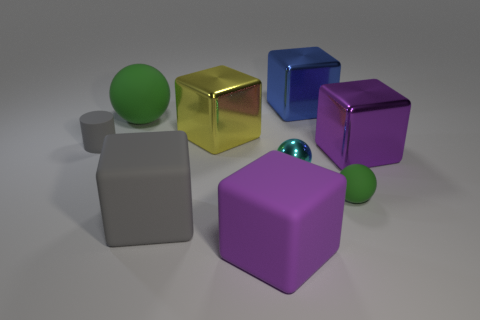What shape is the large matte object that is the same color as the small matte cylinder?
Make the answer very short. Cube. There is a large purple cube behind the purple block that is to the left of the small rubber ball; how many large purple blocks are in front of it?
Provide a short and direct response. 1. How many purple things are right of the large purple rubber block and in front of the small cyan shiny thing?
Offer a very short reply. 0. Is there anything else of the same color as the tiny matte sphere?
Make the answer very short. Yes. How many shiny objects are small green balls or tiny purple cylinders?
Provide a short and direct response. 0. What material is the small ball left of the tiny green matte object that is to the left of the big metallic block that is right of the blue metallic cube?
Your answer should be compact. Metal. There is a small object that is to the left of the large matte object to the right of the large gray rubber block; what is it made of?
Offer a very short reply. Rubber. Is the size of the matte sphere in front of the small gray matte thing the same as the gray rubber object on the right side of the tiny gray cylinder?
Keep it short and to the point. No. Are there any other things that have the same material as the blue block?
Keep it short and to the point. Yes. How many big objects are either yellow metal things or purple objects?
Keep it short and to the point. 3. 